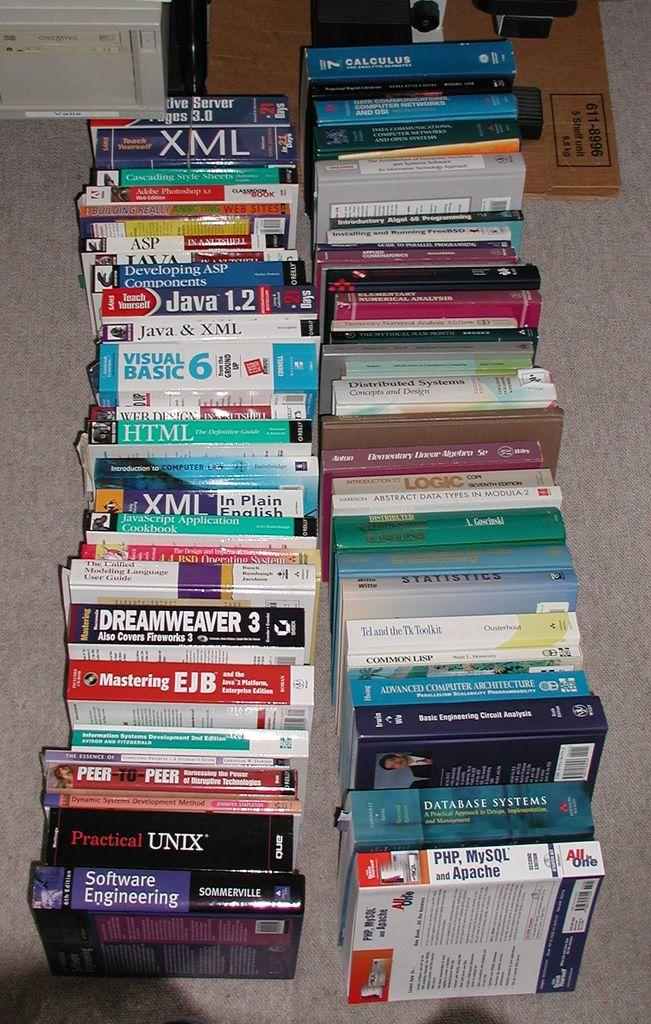<image>
Describe the image concisely. A large collection of books with one named XML. 